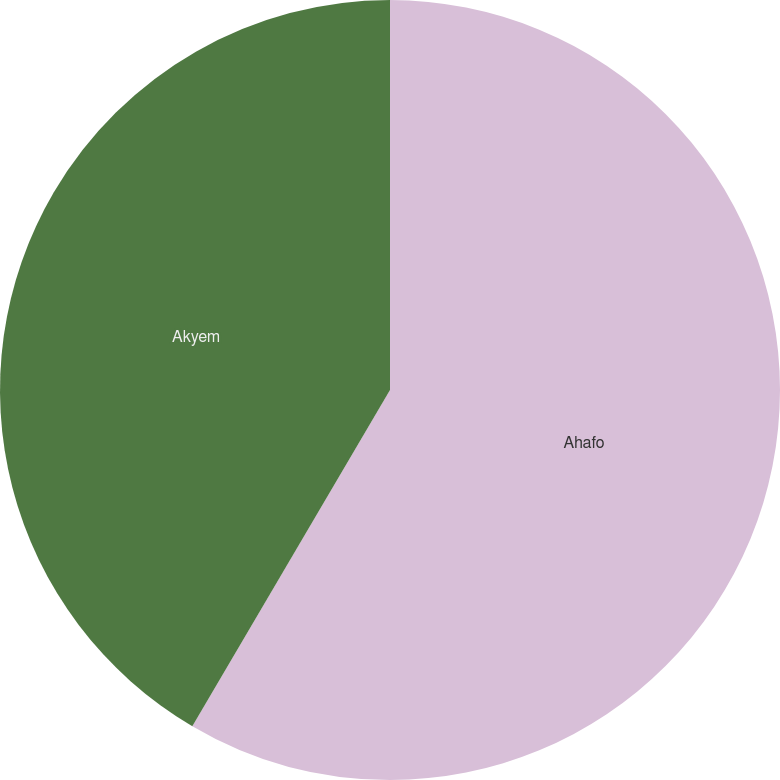Convert chart to OTSL. <chart><loc_0><loc_0><loc_500><loc_500><pie_chart><fcel>Ahafo<fcel>Akyem<nl><fcel>58.46%<fcel>41.54%<nl></chart> 